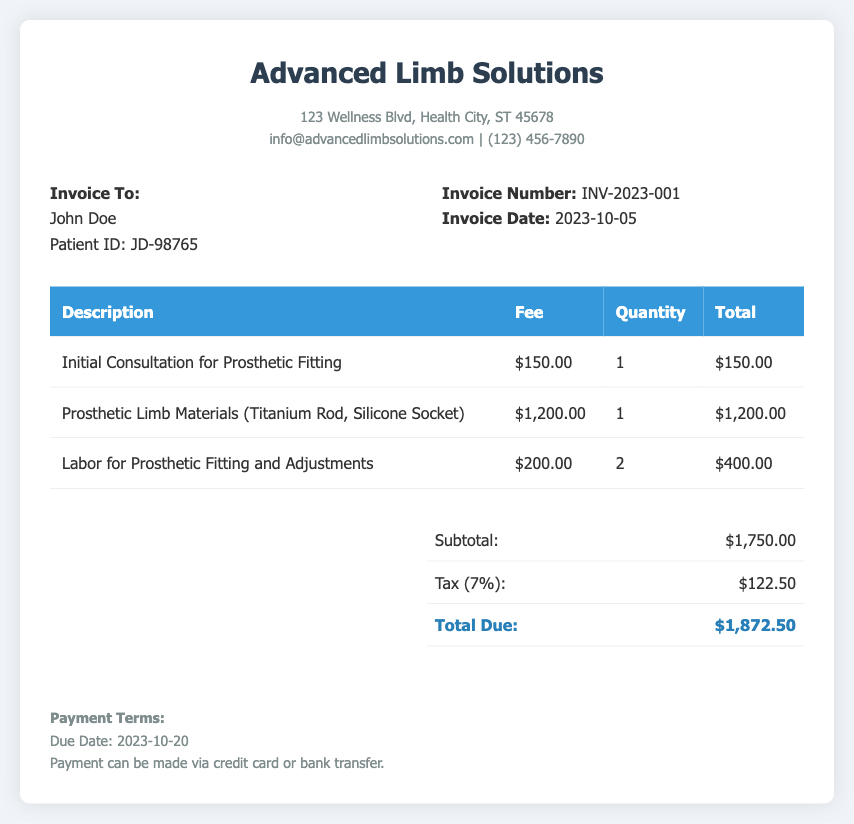What is the invoice number? The invoice number is listed prominently in the document for reference, which is INV-2023-001.
Answer: INV-2023-001 What is the fee for the initial consultation? The fee for the initial consultation for prosthetic fitting is detailed in the document as $150.00.
Answer: $150.00 How much are the prosthetic limb materials? The cost of the prosthetic limb materials, which includes the Titanium Rod and Silicone Socket, is provided as $1,200.00.
Answer: $1,200.00 What is the total due amount? The total due amount is the final sum calculated in the summary section of the invoice, which is $1,872.50.
Answer: $1,872.50 When is the due date for the payment? The due date for the payment is specified in the payment terms section of the document as 2023-10-20.
Answer: 2023-10-20 How many labor hours were charged for prosthetic fitting? The labor for prosthetic fitting and adjustments was charged for a quantity of 2, indicating the number of hours or sessions.
Answer: 2 What percentage is the tax applied? The document states that a tax of 7% is applied to the subtotal indicating the tax percentage.
Answer: 7% Who is the invoice addressed to? The invoice is addressed to the patient named John Doe, mentioned at the top of the details.
Answer: John Doe What is the subtotal before tax? The subtotal before tax is given as $1,750.00, which is the total of all fees listed before tax is added.
Answer: $1,750.00 